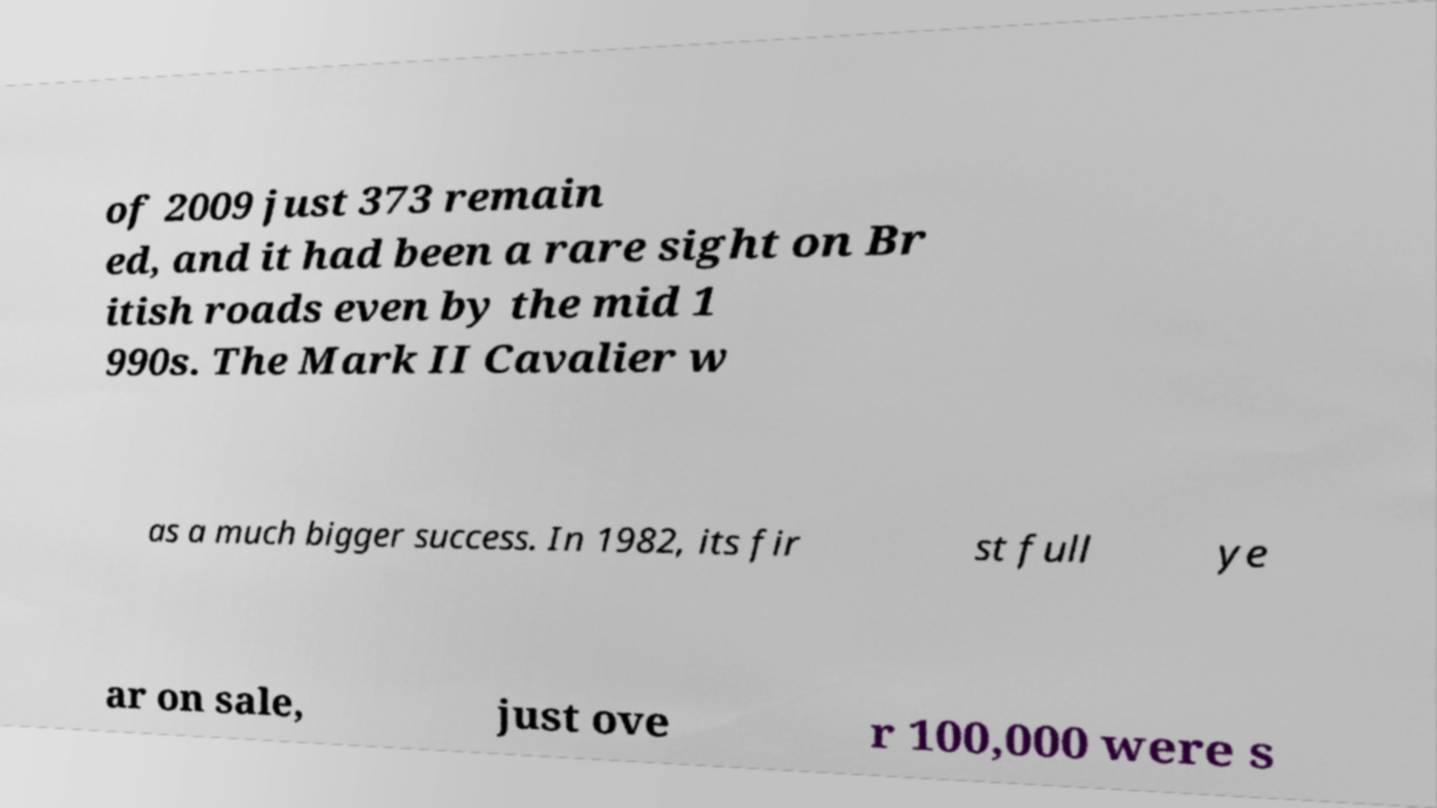I need the written content from this picture converted into text. Can you do that? of 2009 just 373 remain ed, and it had been a rare sight on Br itish roads even by the mid 1 990s. The Mark II Cavalier w as a much bigger success. In 1982, its fir st full ye ar on sale, just ove r 100,000 were s 